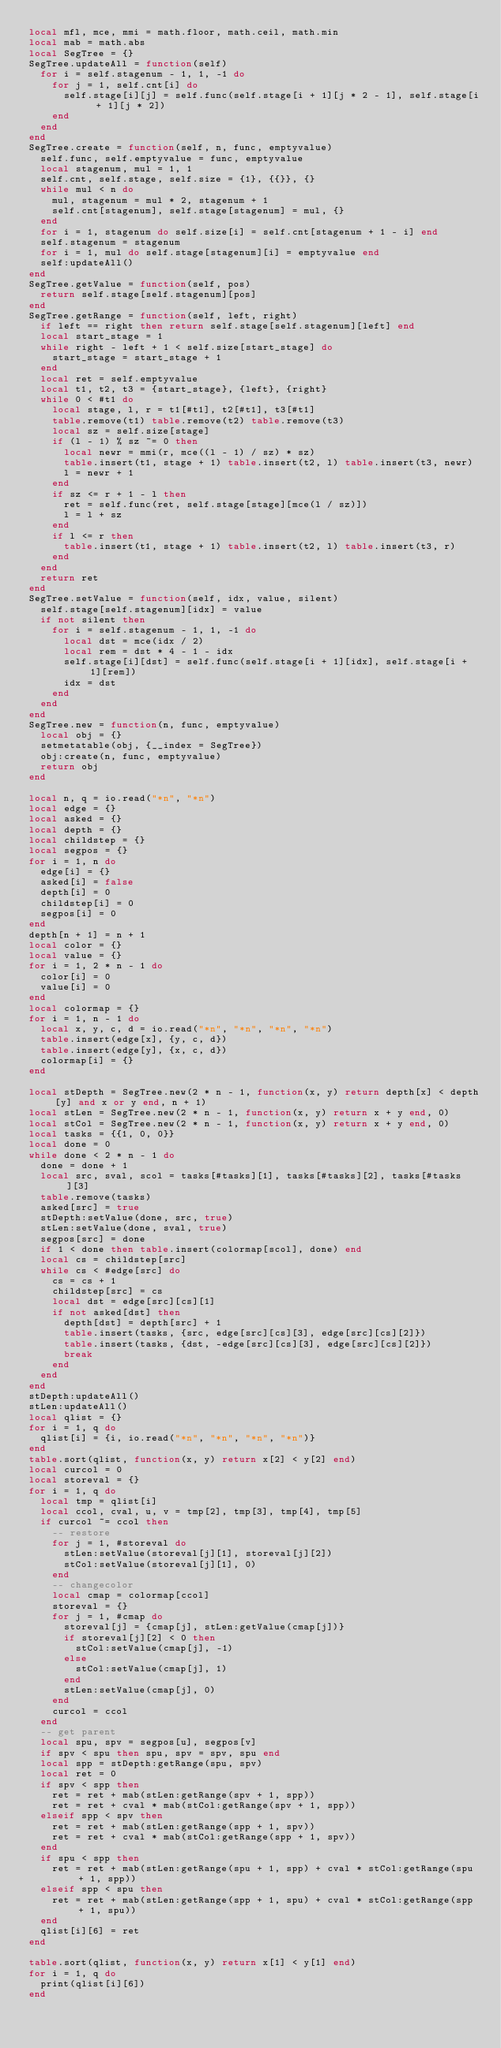Convert code to text. <code><loc_0><loc_0><loc_500><loc_500><_Lua_>local mfl, mce, mmi = math.floor, math.ceil, math.min
local mab = math.abs
local SegTree = {}
SegTree.updateAll = function(self)
  for i = self.stagenum - 1, 1, -1 do
    for j = 1, self.cnt[i] do
      self.stage[i][j] = self.func(self.stage[i + 1][j * 2 - 1], self.stage[i + 1][j * 2])
    end
  end
end
SegTree.create = function(self, n, func, emptyvalue)
  self.func, self.emptyvalue = func, emptyvalue
  local stagenum, mul = 1, 1
  self.cnt, self.stage, self.size = {1}, {{}}, {}
  while mul < n do
    mul, stagenum = mul * 2, stagenum + 1
    self.cnt[stagenum], self.stage[stagenum] = mul, {}
  end
  for i = 1, stagenum do self.size[i] = self.cnt[stagenum + 1 - i] end
  self.stagenum = stagenum
  for i = 1, mul do self.stage[stagenum][i] = emptyvalue end
  self:updateAll()
end
SegTree.getValue = function(self, pos)
  return self.stage[self.stagenum][pos]
end
SegTree.getRange = function(self, left, right)
  if left == right then return self.stage[self.stagenum][left] end
  local start_stage = 1
  while right - left + 1 < self.size[start_stage] do
    start_stage = start_stage + 1
  end
  local ret = self.emptyvalue
  local t1, t2, t3 = {start_stage}, {left}, {right}
  while 0 < #t1 do
    local stage, l, r = t1[#t1], t2[#t1], t3[#t1]
    table.remove(t1) table.remove(t2) table.remove(t3)
    local sz = self.size[stage]
    if (l - 1) % sz ~= 0 then
      local newr = mmi(r, mce((l - 1) / sz) * sz)
      table.insert(t1, stage + 1) table.insert(t2, l) table.insert(t3, newr)
      l = newr + 1
    end
    if sz <= r + 1 - l then
      ret = self.func(ret, self.stage[stage][mce(l / sz)])
      l = l + sz
    end
    if l <= r then
      table.insert(t1, stage + 1) table.insert(t2, l) table.insert(t3, r)
    end
  end
  return ret
end
SegTree.setValue = function(self, idx, value, silent)
  self.stage[self.stagenum][idx] = value
  if not silent then
    for i = self.stagenum - 1, 1, -1 do
      local dst = mce(idx / 2)
      local rem = dst * 4 - 1 - idx
      self.stage[i][dst] = self.func(self.stage[i + 1][idx], self.stage[i + 1][rem])
      idx = dst
    end
  end
end
SegTree.new = function(n, func, emptyvalue)
  local obj = {}
  setmetatable(obj, {__index = SegTree})
  obj:create(n, func, emptyvalue)
  return obj
end

local n, q = io.read("*n", "*n")
local edge = {}
local asked = {}
local depth = {}
local childstep = {}
local segpos = {}
for i = 1, n do
  edge[i] = {}
  asked[i] = false
  depth[i] = 0
  childstep[i] = 0
  segpos[i] = 0
end
depth[n + 1] = n + 1
local color = {}
local value = {}
for i = 1, 2 * n - 1 do
  color[i] = 0
  value[i] = 0
end
local colormap = {}
for i = 1, n - 1 do
  local x, y, c, d = io.read("*n", "*n", "*n", "*n")
  table.insert(edge[x], {y, c, d})
  table.insert(edge[y], {x, c, d})
  colormap[i] = {}
end

local stDepth = SegTree.new(2 * n - 1, function(x, y) return depth[x] < depth[y] and x or y end, n + 1)
local stLen = SegTree.new(2 * n - 1, function(x, y) return x + y end, 0)
local stCol = SegTree.new(2 * n - 1, function(x, y) return x + y end, 0)
local tasks = {{1, 0, 0}}
local done = 0
while done < 2 * n - 1 do
  done = done + 1
  local src, sval, scol = tasks[#tasks][1], tasks[#tasks][2], tasks[#tasks][3]
  table.remove(tasks)
  asked[src] = true
  stDepth:setValue(done, src, true)
  stLen:setValue(done, sval, true)
  segpos[src] = done
  if 1 < done then table.insert(colormap[scol], done) end
  local cs = childstep[src]
  while cs < #edge[src] do
    cs = cs + 1
    childstep[src] = cs
    local dst = edge[src][cs][1]
    if not asked[dst] then
      depth[dst] = depth[src] + 1
      table.insert(tasks, {src, edge[src][cs][3], edge[src][cs][2]})
      table.insert(tasks, {dst, -edge[src][cs][3], edge[src][cs][2]})
      break
    end
  end
end
stDepth:updateAll()
stLen:updateAll()
local qlist = {}
for i = 1, q do
  qlist[i] = {i, io.read("*n", "*n", "*n", "*n")}
end
table.sort(qlist, function(x, y) return x[2] < y[2] end)
local curcol = 0
local storeval = {}
for i = 1, q do
  local tmp = qlist[i]
  local ccol, cval, u, v = tmp[2], tmp[3], tmp[4], tmp[5]
  if curcol ~= ccol then
    -- restore
    for j = 1, #storeval do
      stLen:setValue(storeval[j][1], storeval[j][2])
      stCol:setValue(storeval[j][1], 0)
    end
    -- changecolor
    local cmap = colormap[ccol]
    storeval = {}
    for j = 1, #cmap do
      storeval[j] = {cmap[j], stLen:getValue(cmap[j])}
      if storeval[j][2] < 0 then
        stCol:setValue(cmap[j], -1)
      else
        stCol:setValue(cmap[j], 1)
      end
      stLen:setValue(cmap[j], 0)
    end
    curcol = ccol
  end
  -- get parent
  local spu, spv = segpos[u], segpos[v]
  if spv < spu then spu, spv = spv, spu end
  local spp = stDepth:getRange(spu, spv)
  local ret = 0
  if spv < spp then
    ret = ret + mab(stLen:getRange(spv + 1, spp))
    ret = ret + cval * mab(stCol:getRange(spv + 1, spp))
  elseif spp < spv then
    ret = ret + mab(stLen:getRange(spp + 1, spv))
    ret = ret + cval * mab(stCol:getRange(spp + 1, spv))
  end
  if spu < spp then
    ret = ret + mab(stLen:getRange(spu + 1, spp) + cval * stCol:getRange(spu + 1, spp))
  elseif spp < spu then
    ret = ret + mab(stLen:getRange(spp + 1, spu) + cval * stCol:getRange(spp + 1, spu))
  end
  qlist[i][6] = ret
end

table.sort(qlist, function(x, y) return x[1] < y[1] end)
for i = 1, q do
  print(qlist[i][6])
end
</code> 